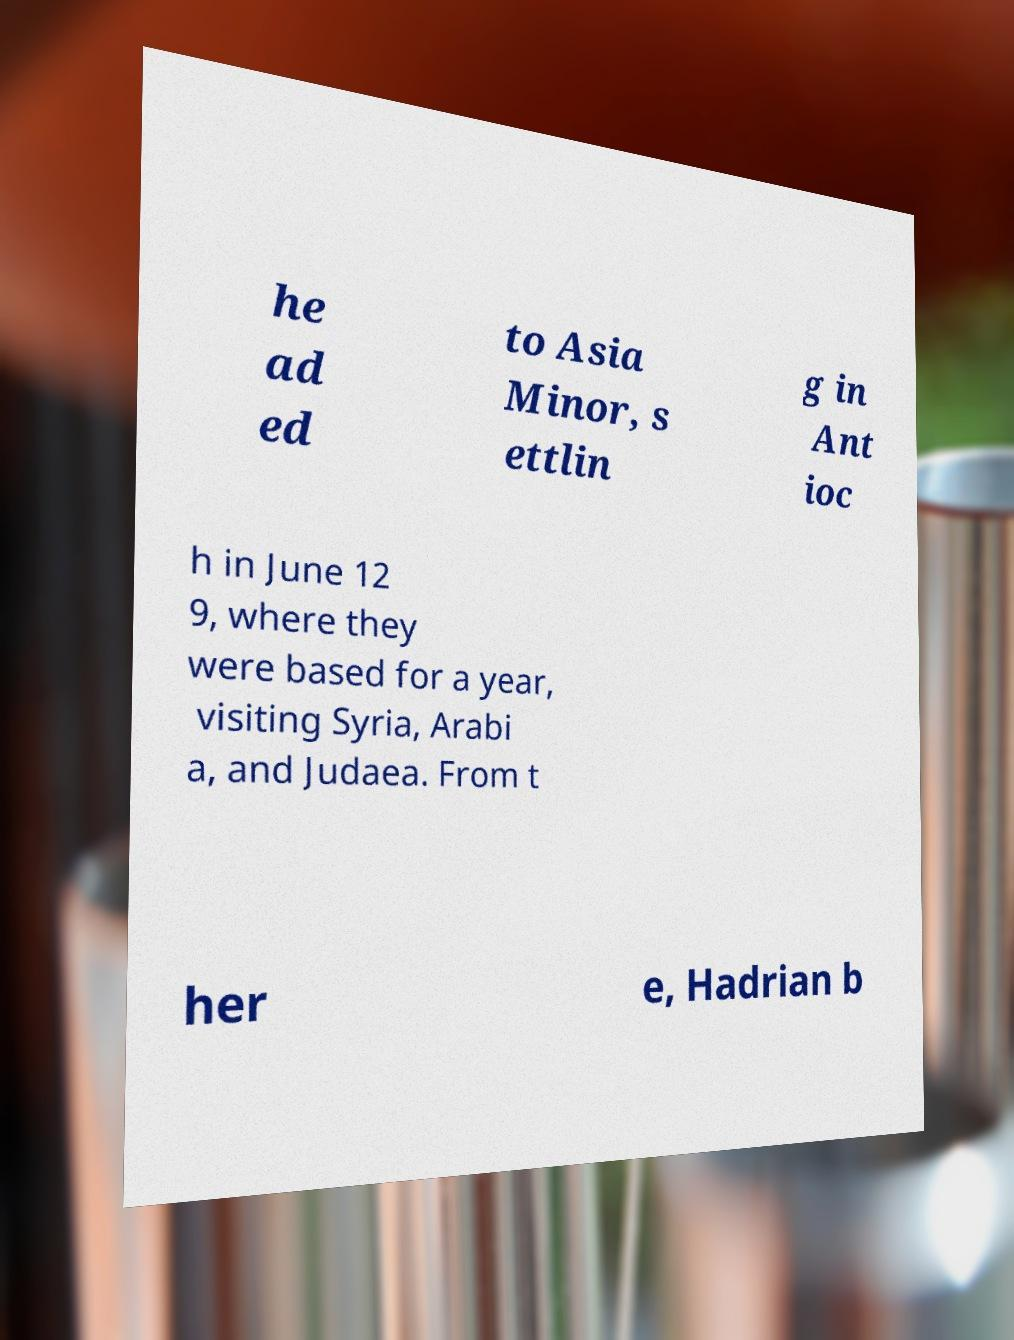For documentation purposes, I need the text within this image transcribed. Could you provide that? he ad ed to Asia Minor, s ettlin g in Ant ioc h in June 12 9, where they were based for a year, visiting Syria, Arabi a, and Judaea. From t her e, Hadrian b 